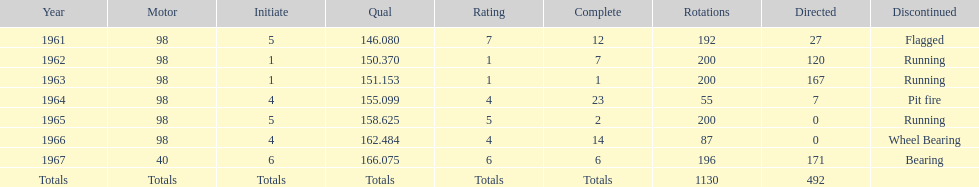Number of times to finish the races running. 3. 